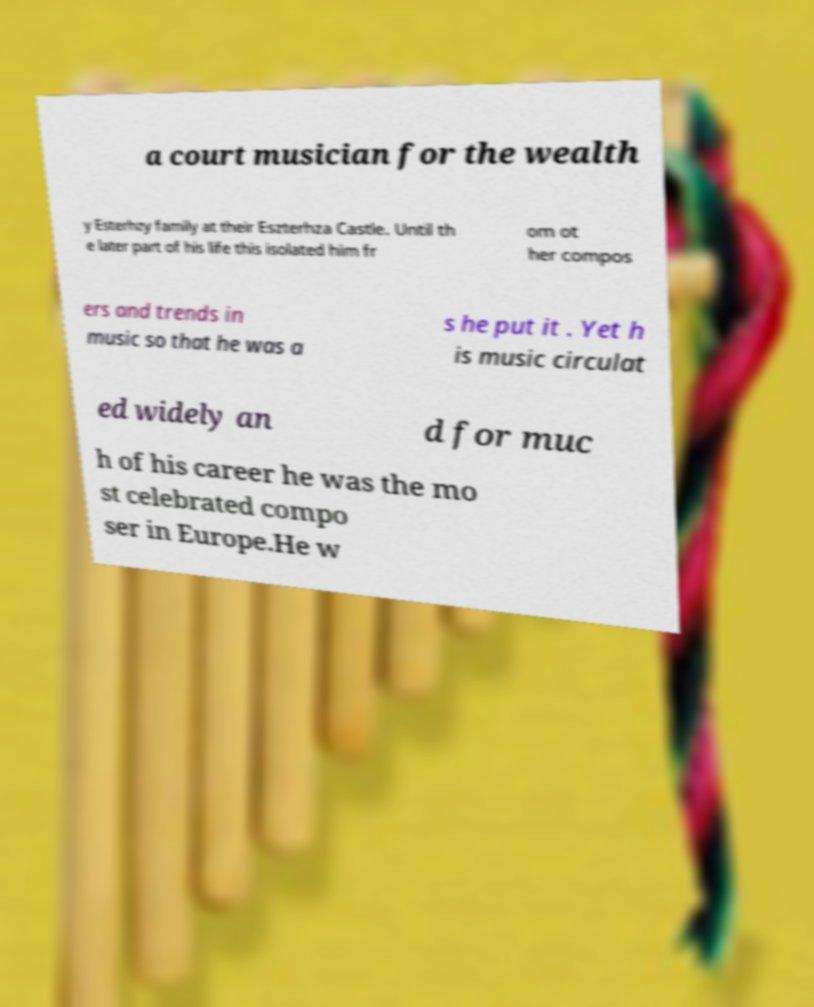Could you assist in decoding the text presented in this image and type it out clearly? a court musician for the wealth y Esterhzy family at their Eszterhza Castle. Until th e later part of his life this isolated him fr om ot her compos ers and trends in music so that he was a s he put it . Yet h is music circulat ed widely an d for muc h of his career he was the mo st celebrated compo ser in Europe.He w 